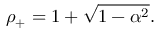Convert formula to latex. <formula><loc_0><loc_0><loc_500><loc_500>\rho _ { + } = 1 + \sqrt { 1 - \alpha ^ { 2 } } .</formula> 